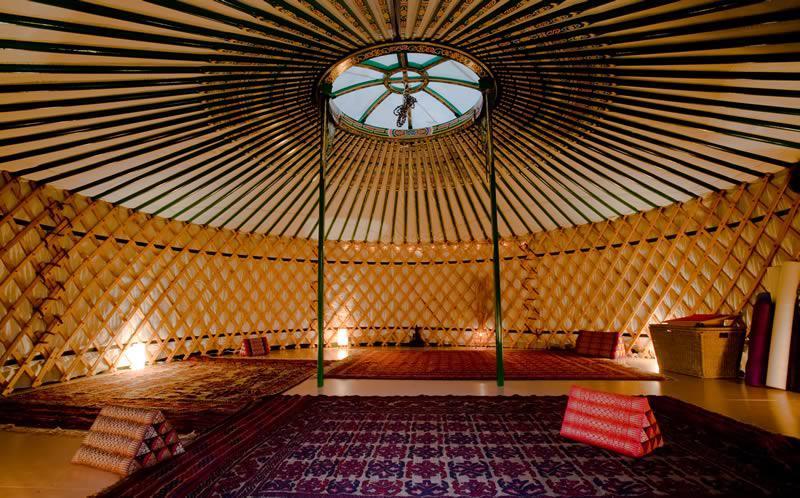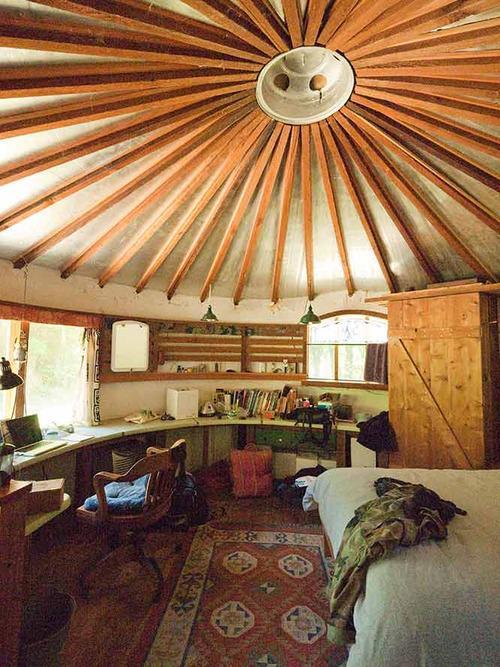The first image is the image on the left, the second image is the image on the right. Examine the images to the left and right. Is the description "The lefthand image shows a yurt interior with an animal hide used in the bedroom decor." accurate? Answer yes or no. No. The first image is the image on the left, the second image is the image on the right. For the images shown, is this caption "In one image, an office area with an oak office chair on wheels and laptop computer is adjacent to the foot of a bed with an oriental rug on the floor." true? Answer yes or no. Yes. 